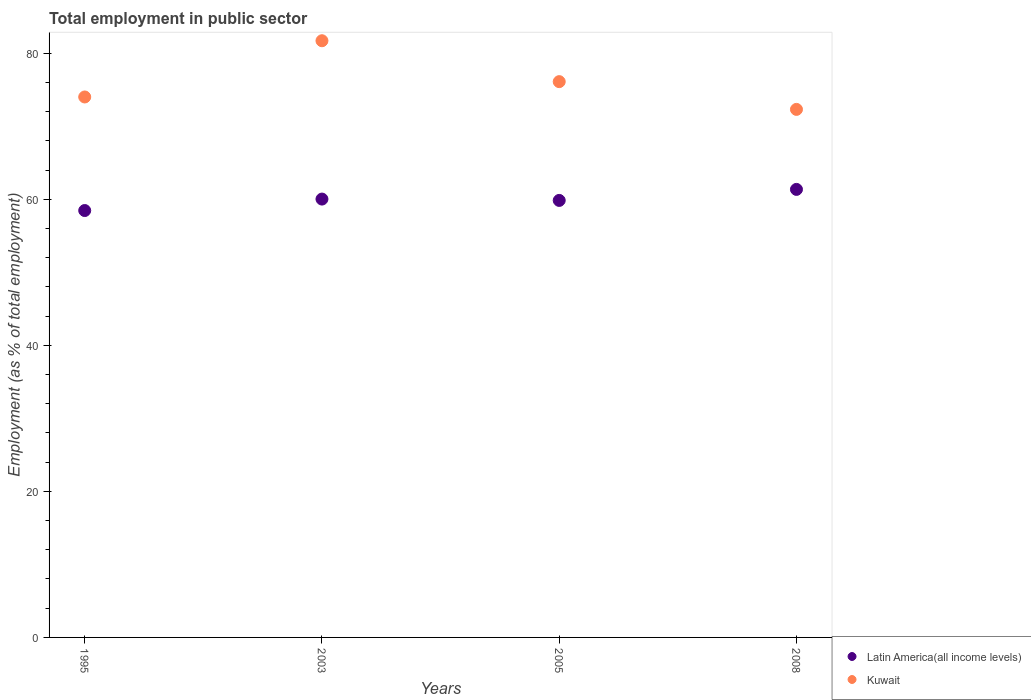Is the number of dotlines equal to the number of legend labels?
Give a very brief answer. Yes. What is the employment in public sector in Kuwait in 2003?
Provide a short and direct response. 81.7. Across all years, what is the maximum employment in public sector in Latin America(all income levels)?
Your answer should be compact. 61.35. Across all years, what is the minimum employment in public sector in Latin America(all income levels)?
Keep it short and to the point. 58.45. In which year was the employment in public sector in Kuwait maximum?
Your answer should be compact. 2003. What is the total employment in public sector in Kuwait in the graph?
Give a very brief answer. 304.1. What is the difference between the employment in public sector in Latin America(all income levels) in 2003 and that in 2005?
Provide a short and direct response. 0.18. What is the difference between the employment in public sector in Latin America(all income levels) in 2003 and the employment in public sector in Kuwait in 2008?
Make the answer very short. -12.28. What is the average employment in public sector in Latin America(all income levels) per year?
Ensure brevity in your answer.  59.91. In the year 2005, what is the difference between the employment in public sector in Kuwait and employment in public sector in Latin America(all income levels)?
Provide a succinct answer. 16.26. In how many years, is the employment in public sector in Kuwait greater than 56 %?
Offer a terse response. 4. What is the ratio of the employment in public sector in Latin America(all income levels) in 2005 to that in 2008?
Give a very brief answer. 0.98. Is the employment in public sector in Latin America(all income levels) in 2003 less than that in 2005?
Ensure brevity in your answer.  No. What is the difference between the highest and the second highest employment in public sector in Kuwait?
Make the answer very short. 5.6. What is the difference between the highest and the lowest employment in public sector in Kuwait?
Provide a succinct answer. 9.4. Is the sum of the employment in public sector in Kuwait in 2005 and 2008 greater than the maximum employment in public sector in Latin America(all income levels) across all years?
Provide a succinct answer. Yes. Is the employment in public sector in Latin America(all income levels) strictly greater than the employment in public sector in Kuwait over the years?
Keep it short and to the point. No. Is the employment in public sector in Latin America(all income levels) strictly less than the employment in public sector in Kuwait over the years?
Provide a succinct answer. Yes. How many dotlines are there?
Your answer should be compact. 2. What is the difference between two consecutive major ticks on the Y-axis?
Make the answer very short. 20. Are the values on the major ticks of Y-axis written in scientific E-notation?
Your response must be concise. No. Does the graph contain grids?
Keep it short and to the point. No. How many legend labels are there?
Provide a short and direct response. 2. What is the title of the graph?
Your response must be concise. Total employment in public sector. Does "South Asia" appear as one of the legend labels in the graph?
Keep it short and to the point. No. What is the label or title of the X-axis?
Offer a terse response. Years. What is the label or title of the Y-axis?
Keep it short and to the point. Employment (as % of total employment). What is the Employment (as % of total employment) of Latin America(all income levels) in 1995?
Make the answer very short. 58.45. What is the Employment (as % of total employment) in Kuwait in 1995?
Make the answer very short. 74. What is the Employment (as % of total employment) of Latin America(all income levels) in 2003?
Offer a terse response. 60.02. What is the Employment (as % of total employment) of Kuwait in 2003?
Your answer should be very brief. 81.7. What is the Employment (as % of total employment) in Latin America(all income levels) in 2005?
Offer a very short reply. 59.84. What is the Employment (as % of total employment) in Kuwait in 2005?
Your response must be concise. 76.1. What is the Employment (as % of total employment) of Latin America(all income levels) in 2008?
Ensure brevity in your answer.  61.35. What is the Employment (as % of total employment) of Kuwait in 2008?
Give a very brief answer. 72.3. Across all years, what is the maximum Employment (as % of total employment) in Latin America(all income levels)?
Offer a very short reply. 61.35. Across all years, what is the maximum Employment (as % of total employment) in Kuwait?
Provide a short and direct response. 81.7. Across all years, what is the minimum Employment (as % of total employment) of Latin America(all income levels)?
Offer a terse response. 58.45. Across all years, what is the minimum Employment (as % of total employment) in Kuwait?
Provide a short and direct response. 72.3. What is the total Employment (as % of total employment) of Latin America(all income levels) in the graph?
Provide a short and direct response. 239.65. What is the total Employment (as % of total employment) of Kuwait in the graph?
Provide a succinct answer. 304.1. What is the difference between the Employment (as % of total employment) of Latin America(all income levels) in 1995 and that in 2003?
Offer a very short reply. -1.57. What is the difference between the Employment (as % of total employment) of Latin America(all income levels) in 1995 and that in 2005?
Your answer should be compact. -1.39. What is the difference between the Employment (as % of total employment) in Kuwait in 1995 and that in 2005?
Offer a terse response. -2.1. What is the difference between the Employment (as % of total employment) in Latin America(all income levels) in 1995 and that in 2008?
Ensure brevity in your answer.  -2.89. What is the difference between the Employment (as % of total employment) in Latin America(all income levels) in 2003 and that in 2005?
Offer a very short reply. 0.18. What is the difference between the Employment (as % of total employment) of Kuwait in 2003 and that in 2005?
Make the answer very short. 5.6. What is the difference between the Employment (as % of total employment) in Latin America(all income levels) in 2003 and that in 2008?
Keep it short and to the point. -1.33. What is the difference between the Employment (as % of total employment) of Latin America(all income levels) in 2005 and that in 2008?
Give a very brief answer. -1.51. What is the difference between the Employment (as % of total employment) in Kuwait in 2005 and that in 2008?
Provide a succinct answer. 3.8. What is the difference between the Employment (as % of total employment) of Latin America(all income levels) in 1995 and the Employment (as % of total employment) of Kuwait in 2003?
Your response must be concise. -23.25. What is the difference between the Employment (as % of total employment) of Latin America(all income levels) in 1995 and the Employment (as % of total employment) of Kuwait in 2005?
Ensure brevity in your answer.  -17.65. What is the difference between the Employment (as % of total employment) of Latin America(all income levels) in 1995 and the Employment (as % of total employment) of Kuwait in 2008?
Your answer should be compact. -13.85. What is the difference between the Employment (as % of total employment) in Latin America(all income levels) in 2003 and the Employment (as % of total employment) in Kuwait in 2005?
Offer a very short reply. -16.08. What is the difference between the Employment (as % of total employment) of Latin America(all income levels) in 2003 and the Employment (as % of total employment) of Kuwait in 2008?
Make the answer very short. -12.28. What is the difference between the Employment (as % of total employment) of Latin America(all income levels) in 2005 and the Employment (as % of total employment) of Kuwait in 2008?
Offer a very short reply. -12.46. What is the average Employment (as % of total employment) in Latin America(all income levels) per year?
Make the answer very short. 59.91. What is the average Employment (as % of total employment) in Kuwait per year?
Your answer should be very brief. 76.03. In the year 1995, what is the difference between the Employment (as % of total employment) in Latin America(all income levels) and Employment (as % of total employment) in Kuwait?
Keep it short and to the point. -15.55. In the year 2003, what is the difference between the Employment (as % of total employment) of Latin America(all income levels) and Employment (as % of total employment) of Kuwait?
Offer a terse response. -21.68. In the year 2005, what is the difference between the Employment (as % of total employment) in Latin America(all income levels) and Employment (as % of total employment) in Kuwait?
Provide a short and direct response. -16.26. In the year 2008, what is the difference between the Employment (as % of total employment) in Latin America(all income levels) and Employment (as % of total employment) in Kuwait?
Ensure brevity in your answer.  -10.95. What is the ratio of the Employment (as % of total employment) of Latin America(all income levels) in 1995 to that in 2003?
Keep it short and to the point. 0.97. What is the ratio of the Employment (as % of total employment) of Kuwait in 1995 to that in 2003?
Your answer should be very brief. 0.91. What is the ratio of the Employment (as % of total employment) of Latin America(all income levels) in 1995 to that in 2005?
Provide a short and direct response. 0.98. What is the ratio of the Employment (as % of total employment) in Kuwait in 1995 to that in 2005?
Offer a terse response. 0.97. What is the ratio of the Employment (as % of total employment) of Latin America(all income levels) in 1995 to that in 2008?
Ensure brevity in your answer.  0.95. What is the ratio of the Employment (as % of total employment) in Kuwait in 1995 to that in 2008?
Your answer should be compact. 1.02. What is the ratio of the Employment (as % of total employment) in Latin America(all income levels) in 2003 to that in 2005?
Give a very brief answer. 1. What is the ratio of the Employment (as % of total employment) of Kuwait in 2003 to that in 2005?
Your answer should be compact. 1.07. What is the ratio of the Employment (as % of total employment) of Latin America(all income levels) in 2003 to that in 2008?
Your answer should be very brief. 0.98. What is the ratio of the Employment (as % of total employment) of Kuwait in 2003 to that in 2008?
Offer a very short reply. 1.13. What is the ratio of the Employment (as % of total employment) in Latin America(all income levels) in 2005 to that in 2008?
Offer a terse response. 0.98. What is the ratio of the Employment (as % of total employment) of Kuwait in 2005 to that in 2008?
Give a very brief answer. 1.05. What is the difference between the highest and the second highest Employment (as % of total employment) of Latin America(all income levels)?
Your answer should be compact. 1.33. What is the difference between the highest and the second highest Employment (as % of total employment) of Kuwait?
Give a very brief answer. 5.6. What is the difference between the highest and the lowest Employment (as % of total employment) in Latin America(all income levels)?
Offer a very short reply. 2.89. What is the difference between the highest and the lowest Employment (as % of total employment) in Kuwait?
Your answer should be compact. 9.4. 